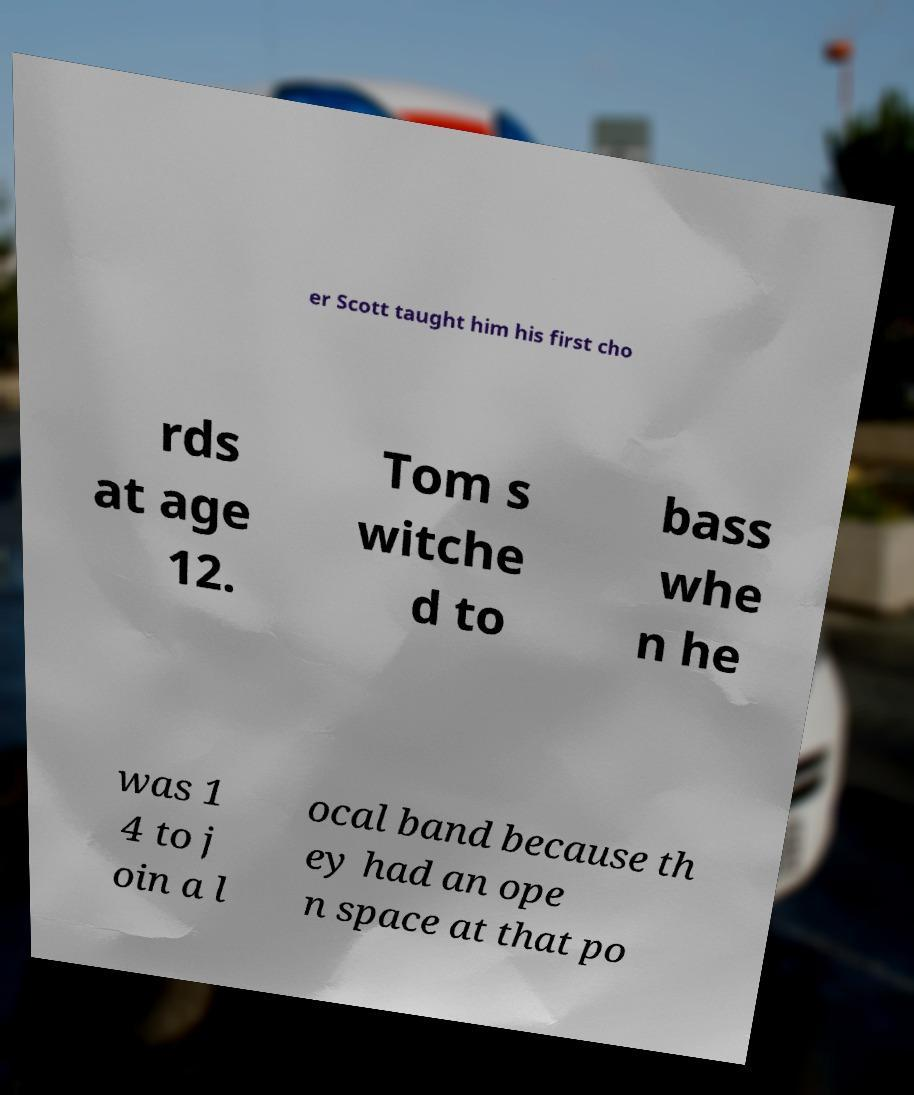Please identify and transcribe the text found in this image. er Scott taught him his first cho rds at age 12. Tom s witche d to bass whe n he was 1 4 to j oin a l ocal band because th ey had an ope n space at that po 